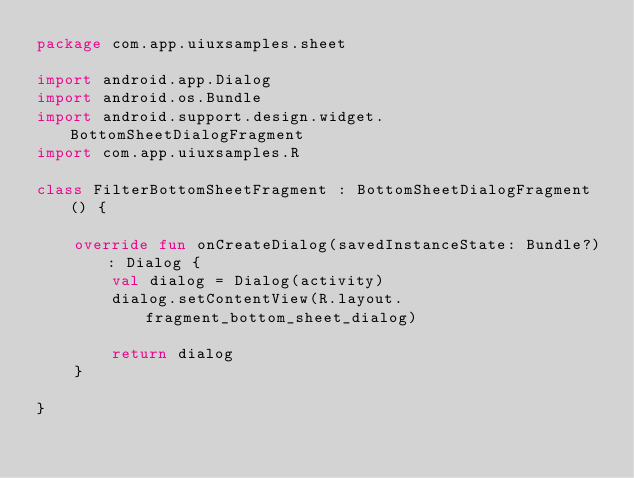<code> <loc_0><loc_0><loc_500><loc_500><_Kotlin_>package com.app.uiuxsamples.sheet

import android.app.Dialog
import android.os.Bundle
import android.support.design.widget.BottomSheetDialogFragment
import com.app.uiuxsamples.R

class FilterBottomSheetFragment : BottomSheetDialogFragment() {

    override fun onCreateDialog(savedInstanceState: Bundle?): Dialog {
        val dialog = Dialog(activity)
        dialog.setContentView(R.layout.fragment_bottom_sheet_dialog)

        return dialog
    }

}</code> 